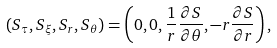Convert formula to latex. <formula><loc_0><loc_0><loc_500><loc_500>( S _ { \tau } , S _ { \xi } , S _ { r } , S _ { \theta } ) = \left ( 0 , 0 , \frac { 1 } { r } \frac { \partial S } { \partial \theta } , - r \frac { \partial S } { \partial r } \right ) ,</formula> 